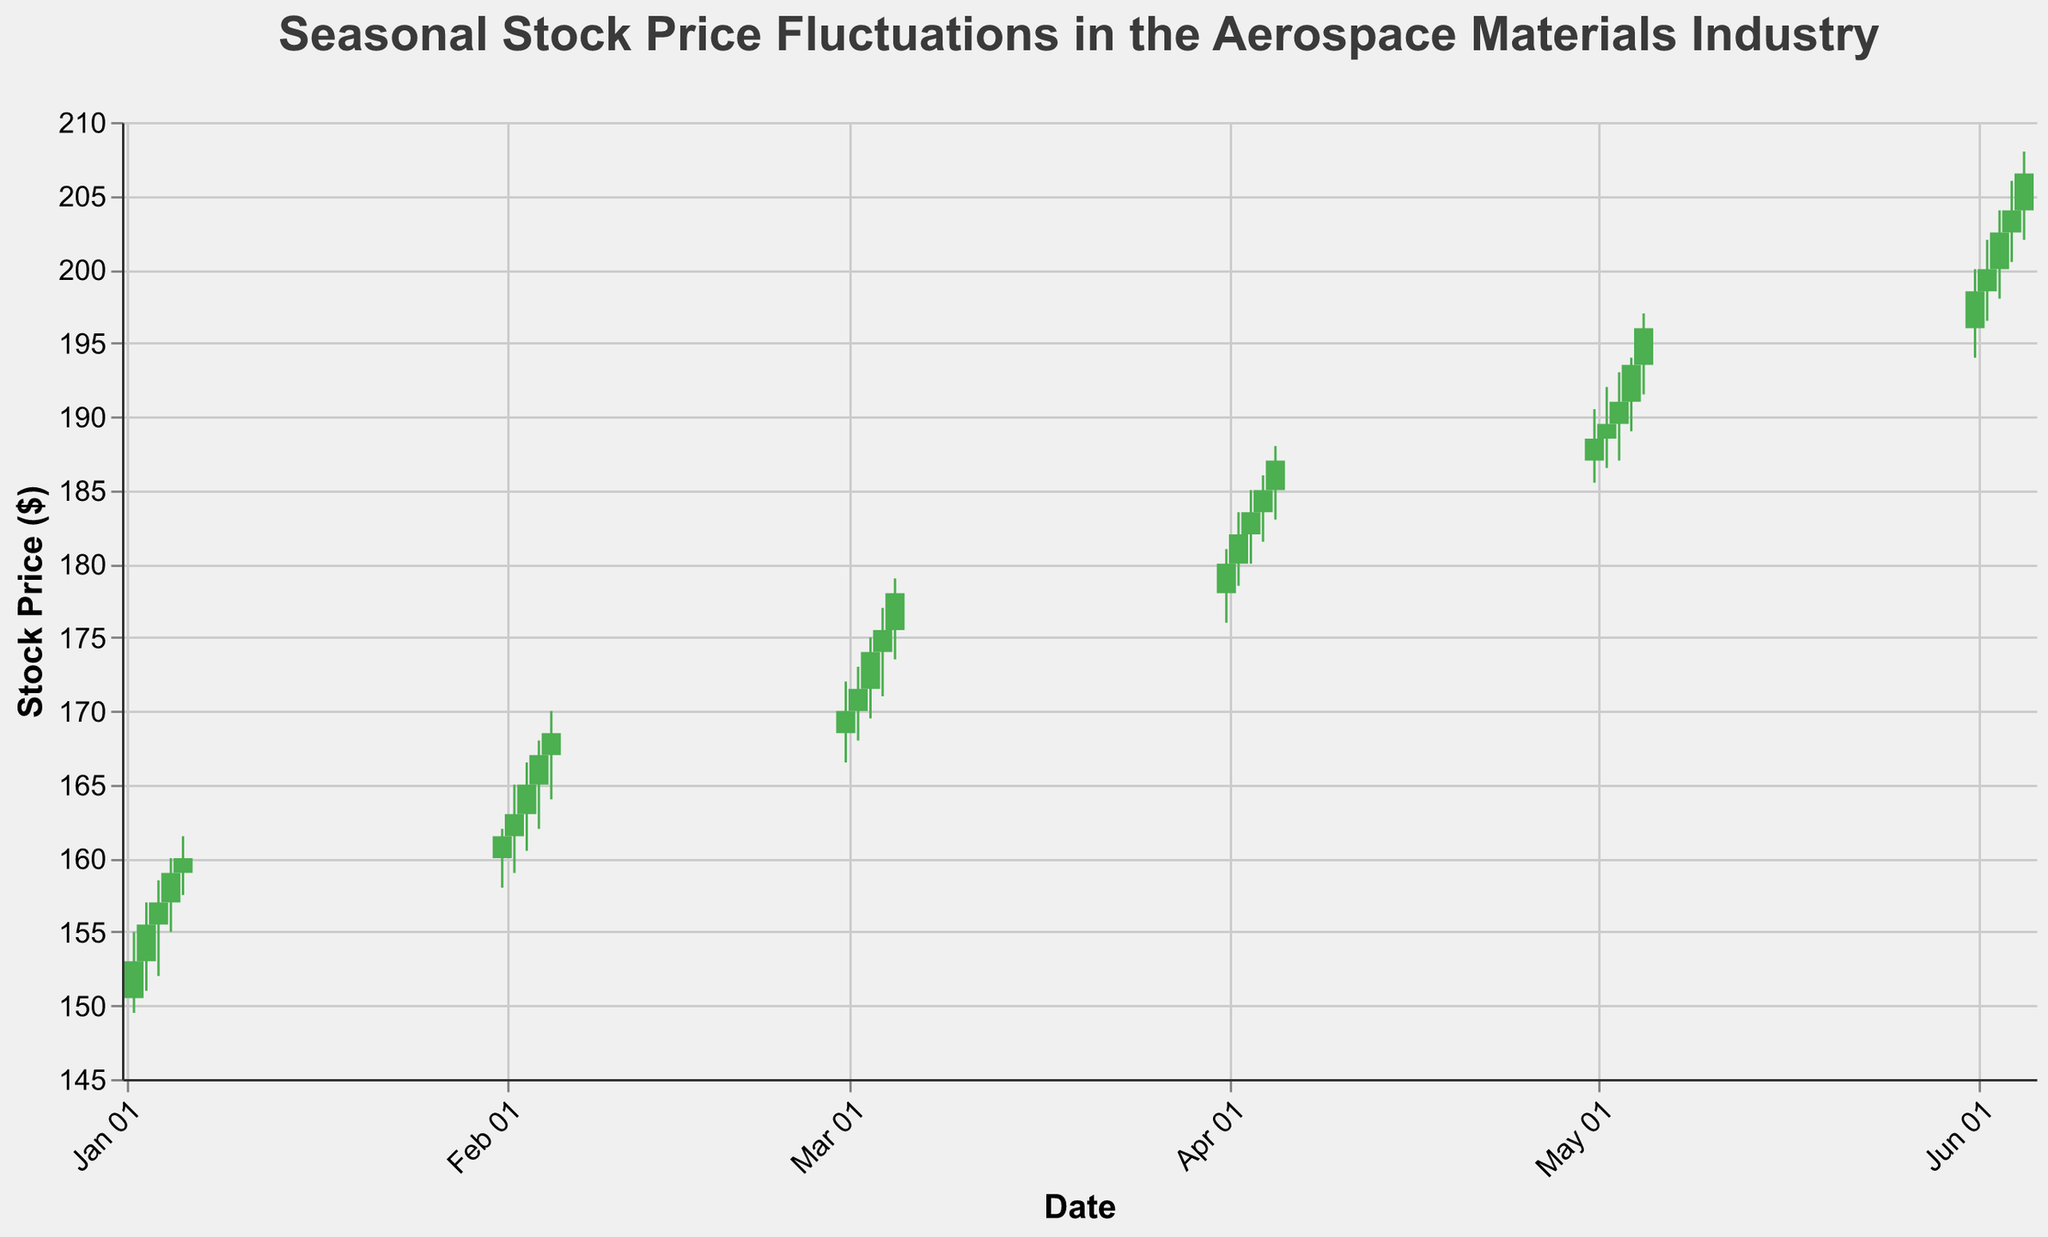Which month shows the highest closing stock price? By looking at the y-axis (Stock Price $) and the month-labels along the x-axis (Date), identify the highest stock price reflected by the topmost bar. June has the highest closing stock price, reaching $206.5 on June 5th.
Answer: June How does the trading volume trend change from January to June? Check the increasing volume numbers along with the time period from January to June. Recognize that the volume steadily increases, moving from 2,504,300 in early January to 5,603,400 in early June.
Answer: Increases What is the opening stock price on February 5th? Look at the candlestick for February 5th and identify the starting point of the bar, which represents the opening price, register it as $167.0.
Answer: $167.0 Which day in April has the highest trading volume? Compare volumes of all the days in April using the information provided. Identify that April 5th has the highest volume with 4,345,800.
Answer: April 5th By how much did the stock price increase from January 2nd to June 5th? Calculate the difference between the closing price on January 2nd ($153.0) and June 5th ($206.5). Subtracting 153.0 from 206.5 yields the increase of 53.5.
Answer: $53.5 What is the average closing price in March? To find the average, sum the closing prices in March (170.0, 171.5, 174.0, 175.5, 178.0) and divide by the number of entries (5). (170.0 + 171.5 + 174.0 + 175.5 + 178.0) / 5 = 173.8
Answer: $173.8 Between which two months did the largest increase in closing price occur? Compare the monthly closing prices. February's end at $168.5 and March's at $178.0 show the largest rise of $9.5.
Answer: February and March On which day in January was the stock price the lowest? Look for the lowest point on the y-axis for each candlestick in January. The lowest value occurred on January 2nd with a low of $149.5.
Answer: January 2nd What is the range of stock prices on March 2nd? Determine the range by subtracting the low ($168.0) from the high ($173.0) of that day, yielding a range of $5.0.
Answer: $5.0 Which candlestick is the longest in May? Measure the range between the lowest and highest points of each candlestick in May. The candlestick on May 5th ($191.5 to $197.0) is the longest with a range of $5.5.
Answer: May 5th 